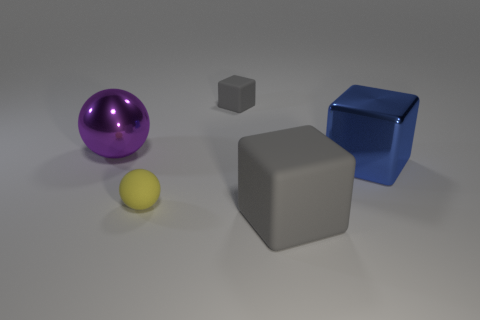Add 2 shiny objects. How many objects exist? 7 Subtract all cubes. How many objects are left? 2 Subtract all brown shiny things. Subtract all tiny rubber things. How many objects are left? 3 Add 2 large gray matte cubes. How many large gray matte cubes are left? 3 Add 4 large blue objects. How many large blue objects exist? 5 Subtract 0 red cylinders. How many objects are left? 5 